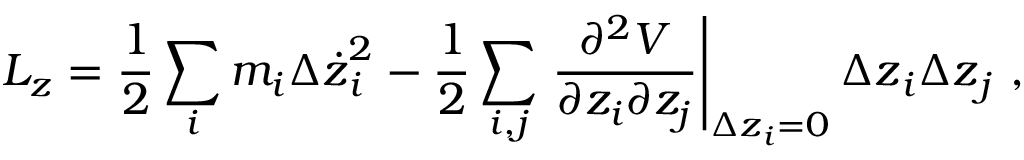<formula> <loc_0><loc_0><loc_500><loc_500>L _ { z } = \frac { 1 } { 2 } \sum _ { i } { m _ { i } { \Delta \dot { z } } _ { i } ^ { 2 } } - \frac { 1 } { 2 } \sum _ { i , j } { \frac { \partial ^ { 2 } V } { \partial z _ { i } \partial z _ { j } } \right | _ { { \Delta z } _ { i } = 0 } { \Delta z } _ { i } { \Delta z } _ { j } } ,</formula> 